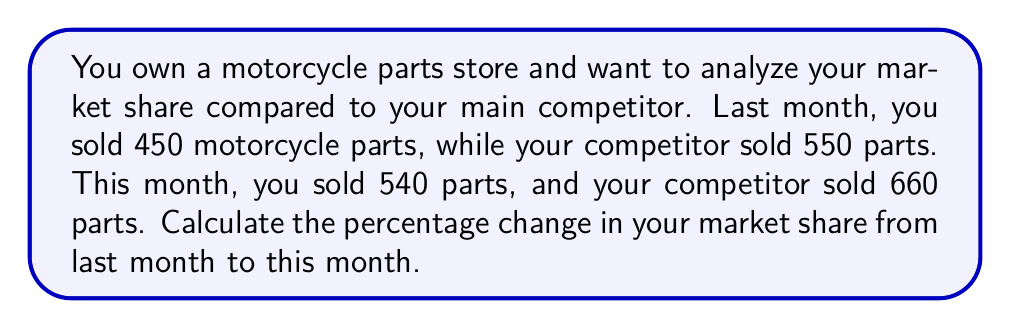Help me with this question. To solve this problem, we need to follow these steps:

1. Calculate the market share for each month:
   Market share = Your sales / Total sales

2. Last month's market share:
   $$\text{Market share}_{\text{last}} = \frac{450}{450 + 550} = \frac{450}{1000} = 0.45 \text{ or } 45\%$$

3. This month's market share:
   $$\text{Market share}_{\text{this}} = \frac{540}{540 + 660} = \frac{540}{1200} = 0.45 \text{ or } 45\%$$

4. Calculate the percentage change in market share:
   $$\text{Percentage change} = \frac{\text{New value} - \text{Original value}}{\text{Original value}} \times 100\%$$
   
   $$\text{Percentage change} = \frac{0.45 - 0.45}{0.45} \times 100\% = 0\%$$

The percentage change in market share is 0%, which means your market share has remained constant despite an increase in total sales for both stores.
Answer: 0% 